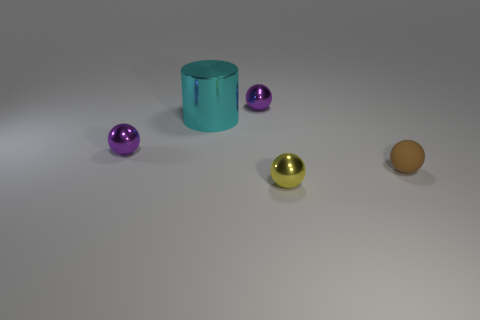Are there any other things that are the same material as the brown sphere?
Ensure brevity in your answer.  No. Are there any other things that have the same size as the metal cylinder?
Give a very brief answer. No. How many other things are the same material as the cyan cylinder?
Provide a short and direct response. 3. What number of objects are either objects in front of the rubber object or tiny objects to the left of the yellow shiny sphere?
Keep it short and to the point. 3. There is a yellow object that is the same shape as the small brown matte thing; what is it made of?
Make the answer very short. Metal. Are there any gray metal cylinders?
Ensure brevity in your answer.  No. What is the size of the metal thing that is both on the right side of the cyan cylinder and to the left of the yellow shiny ball?
Ensure brevity in your answer.  Small. The cyan shiny thing is what shape?
Your answer should be compact. Cylinder. Is there a purple ball behind the sphere right of the yellow metal ball?
Keep it short and to the point. Yes. There is a yellow thing that is the same size as the brown ball; what is its material?
Your response must be concise. Metal. 